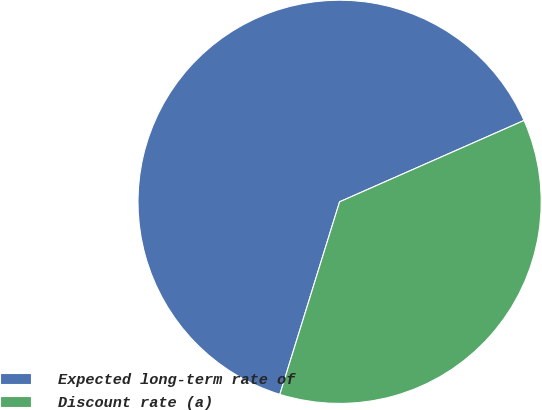Convert chart. <chart><loc_0><loc_0><loc_500><loc_500><pie_chart><fcel>Expected long-term rate of<fcel>Discount rate (a)<nl><fcel>63.6%<fcel>36.4%<nl></chart> 